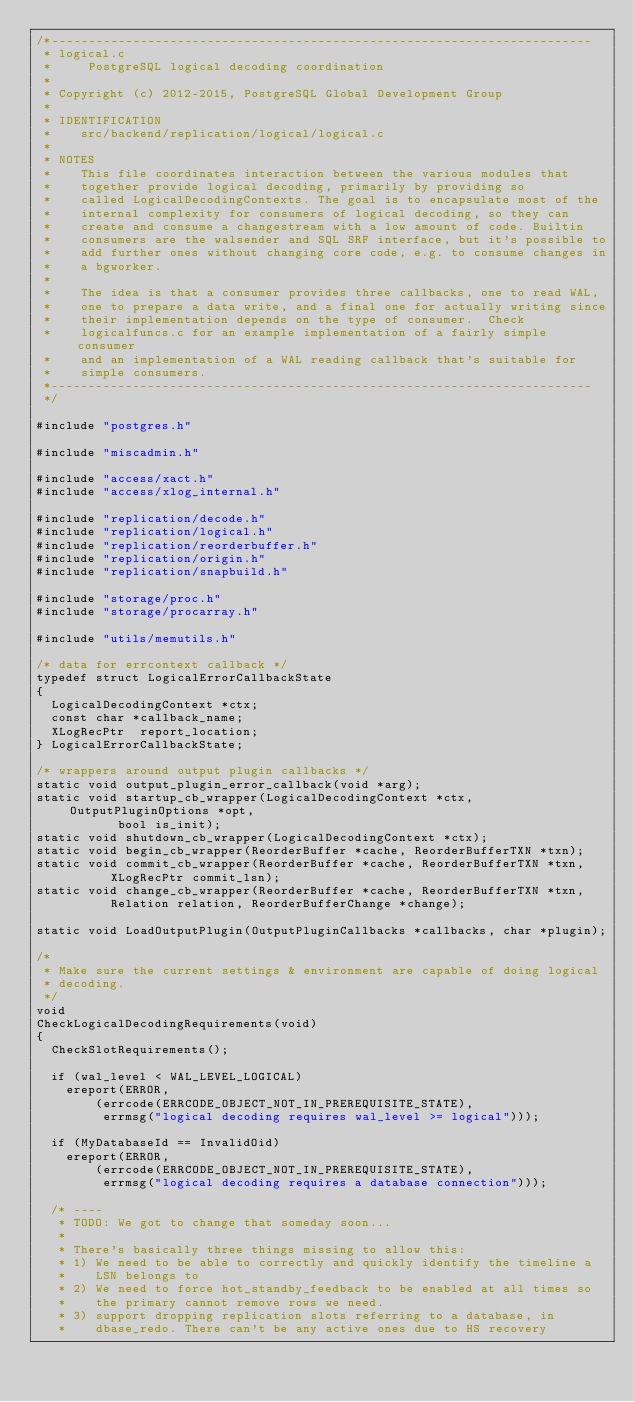<code> <loc_0><loc_0><loc_500><loc_500><_C_>/*-------------------------------------------------------------------------
 * logical.c
 *	   PostgreSQL logical decoding coordination
 *
 * Copyright (c) 2012-2015, PostgreSQL Global Development Group
 *
 * IDENTIFICATION
 *	  src/backend/replication/logical/logical.c
 *
 * NOTES
 *	  This file coordinates interaction between the various modules that
 *	  together provide logical decoding, primarily by providing so
 *	  called LogicalDecodingContexts. The goal is to encapsulate most of the
 *	  internal complexity for consumers of logical decoding, so they can
 *	  create and consume a changestream with a low amount of code. Builtin
 *	  consumers are the walsender and SQL SRF interface, but it's possible to
 *	  add further ones without changing core code, e.g. to consume changes in
 *	  a bgworker.
 *
 *	  The idea is that a consumer provides three callbacks, one to read WAL,
 *	  one to prepare a data write, and a final one for actually writing since
 *	  their implementation depends on the type of consumer.  Check
 *	  logicalfuncs.c for an example implementation of a fairly simple consumer
 *	  and an implementation of a WAL reading callback that's suitable for
 *	  simple consumers.
 *-------------------------------------------------------------------------
 */

#include "postgres.h"

#include "miscadmin.h"

#include "access/xact.h"
#include "access/xlog_internal.h"

#include "replication/decode.h"
#include "replication/logical.h"
#include "replication/reorderbuffer.h"
#include "replication/origin.h"
#include "replication/snapbuild.h"

#include "storage/proc.h"
#include "storage/procarray.h"

#include "utils/memutils.h"

/* data for errcontext callback */
typedef struct LogicalErrorCallbackState
{
	LogicalDecodingContext *ctx;
	const char *callback_name;
	XLogRecPtr	report_location;
} LogicalErrorCallbackState;

/* wrappers around output plugin callbacks */
static void output_plugin_error_callback(void *arg);
static void startup_cb_wrapper(LogicalDecodingContext *ctx, OutputPluginOptions *opt,
				   bool is_init);
static void shutdown_cb_wrapper(LogicalDecodingContext *ctx);
static void begin_cb_wrapper(ReorderBuffer *cache, ReorderBufferTXN *txn);
static void commit_cb_wrapper(ReorderBuffer *cache, ReorderBufferTXN *txn,
				  XLogRecPtr commit_lsn);
static void change_cb_wrapper(ReorderBuffer *cache, ReorderBufferTXN *txn,
				  Relation relation, ReorderBufferChange *change);

static void LoadOutputPlugin(OutputPluginCallbacks *callbacks, char *plugin);

/*
 * Make sure the current settings & environment are capable of doing logical
 * decoding.
 */
void
CheckLogicalDecodingRequirements(void)
{
	CheckSlotRequirements();

	if (wal_level < WAL_LEVEL_LOGICAL)
		ereport(ERROR,
				(errcode(ERRCODE_OBJECT_NOT_IN_PREREQUISITE_STATE),
				 errmsg("logical decoding requires wal_level >= logical")));

	if (MyDatabaseId == InvalidOid)
		ereport(ERROR,
				(errcode(ERRCODE_OBJECT_NOT_IN_PREREQUISITE_STATE),
				 errmsg("logical decoding requires a database connection")));

	/* ----
	 * TODO: We got to change that someday soon...
	 *
	 * There's basically three things missing to allow this:
	 * 1) We need to be able to correctly and quickly identify the timeline a
	 *	  LSN belongs to
	 * 2) We need to force hot_standby_feedback to be enabled at all times so
	 *	  the primary cannot remove rows we need.
	 * 3) support dropping replication slots referring to a database, in
	 *	  dbase_redo. There can't be any active ones due to HS recovery</code> 